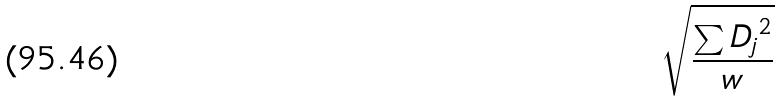<formula> <loc_0><loc_0><loc_500><loc_500>\sqrt { \frac { \sum { D _ { j } } ^ { 2 } } { w } }</formula> 